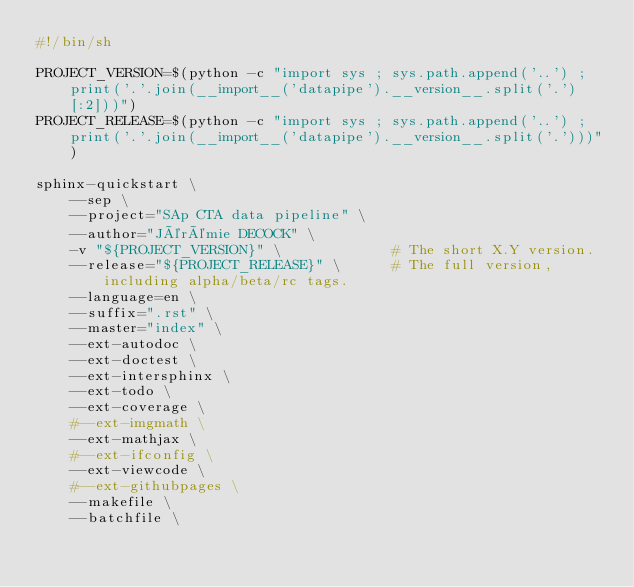<code> <loc_0><loc_0><loc_500><loc_500><_Bash_>#!/bin/sh

PROJECT_VERSION=$(python -c "import sys ; sys.path.append('..') ; print('.'.join(__import__('datapipe').__version__.split('.')[:2]))")
PROJECT_RELEASE=$(python -c "import sys ; sys.path.append('..') ; print('.'.join(__import__('datapipe').__version__.split('.')))")

sphinx-quickstart \
    --sep \
    --project="SAp CTA data pipeline" \
    --author="Jérémie DECOCK" \
    -v "${PROJECT_VERSION}" \             # The short X.Y version.
    --release="${PROJECT_RELEASE}" \      # The full version, including alpha/beta/rc tags.
    --language=en \
    --suffix=".rst" \
    --master="index" \
    --ext-autodoc \
    --ext-doctest \
    --ext-intersphinx \
    --ext-todo \
    --ext-coverage \
    #--ext-imgmath \
    --ext-mathjax \
    #--ext-ifconfig \
    --ext-viewcode \
    #--ext-githubpages \
    --makefile \
    --batchfile \


</code> 